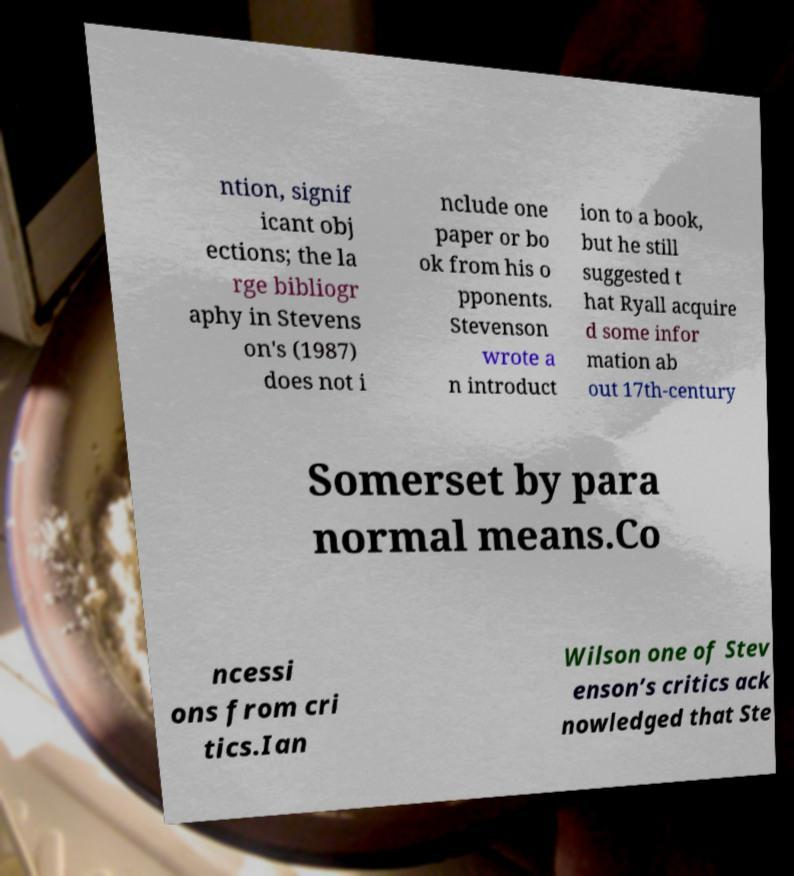Please identify and transcribe the text found in this image. ntion, signif icant obj ections; the la rge bibliogr aphy in Stevens on's (1987) does not i nclude one paper or bo ok from his o pponents. Stevenson wrote a n introduct ion to a book, but he still suggested t hat Ryall acquire d some infor mation ab out 17th-century Somerset by para normal means.Co ncessi ons from cri tics.Ian Wilson one of Stev enson’s critics ack nowledged that Ste 